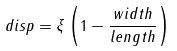Convert formula to latex. <formula><loc_0><loc_0><loc_500><loc_500>d i s p = \xi \left ( 1 - \frac { w i d t h } { l e n g t h } \right )</formula> 